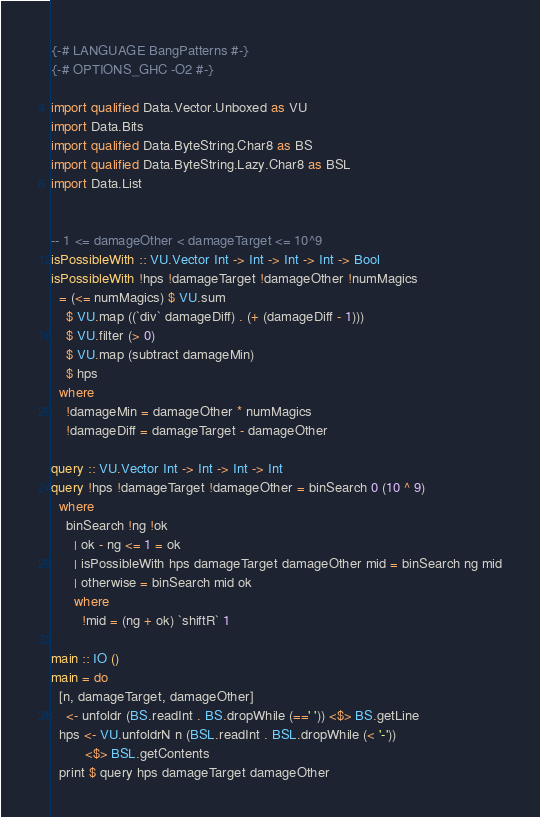<code> <loc_0><loc_0><loc_500><loc_500><_Haskell_>{-# LANGUAGE BangPatterns #-}
{-# OPTIONS_GHC -O2 #-}

import qualified Data.Vector.Unboxed as VU
import Data.Bits
import qualified Data.ByteString.Char8 as BS
import qualified Data.ByteString.Lazy.Char8 as BSL
import Data.List


-- 1 <= damageOther < damageTarget <= 10^9
isPossibleWith :: VU.Vector Int -> Int -> Int -> Int -> Bool
isPossibleWith !hps !damageTarget !damageOther !numMagics
  = (<= numMagics) $ VU.sum
    $ VU.map ((`div` damageDiff) . (+ (damageDiff - 1)))
    $ VU.filter (> 0)
    $ VU.map (subtract damageMin)
    $ hps
  where
    !damageMin = damageOther * numMagics
    !damageDiff = damageTarget - damageOther

query :: VU.Vector Int -> Int -> Int -> Int
query !hps !damageTarget !damageOther = binSearch 0 (10 ^ 9)
  where
    binSearch !ng !ok
      | ok - ng <= 1 = ok
      | isPossibleWith hps damageTarget damageOther mid = binSearch ng mid
      | otherwise = binSearch mid ok
      where
        !mid = (ng + ok) `shiftR` 1

main :: IO ()
main = do
  [n, damageTarget, damageOther]
    <- unfoldr (BS.readInt . BS.dropWhile (==' ')) <$> BS.getLine
  hps <- VU.unfoldrN n (BSL.readInt . BSL.dropWhile (< '-'))
         <$> BSL.getContents
  print $ query hps damageTarget damageOther
</code> 